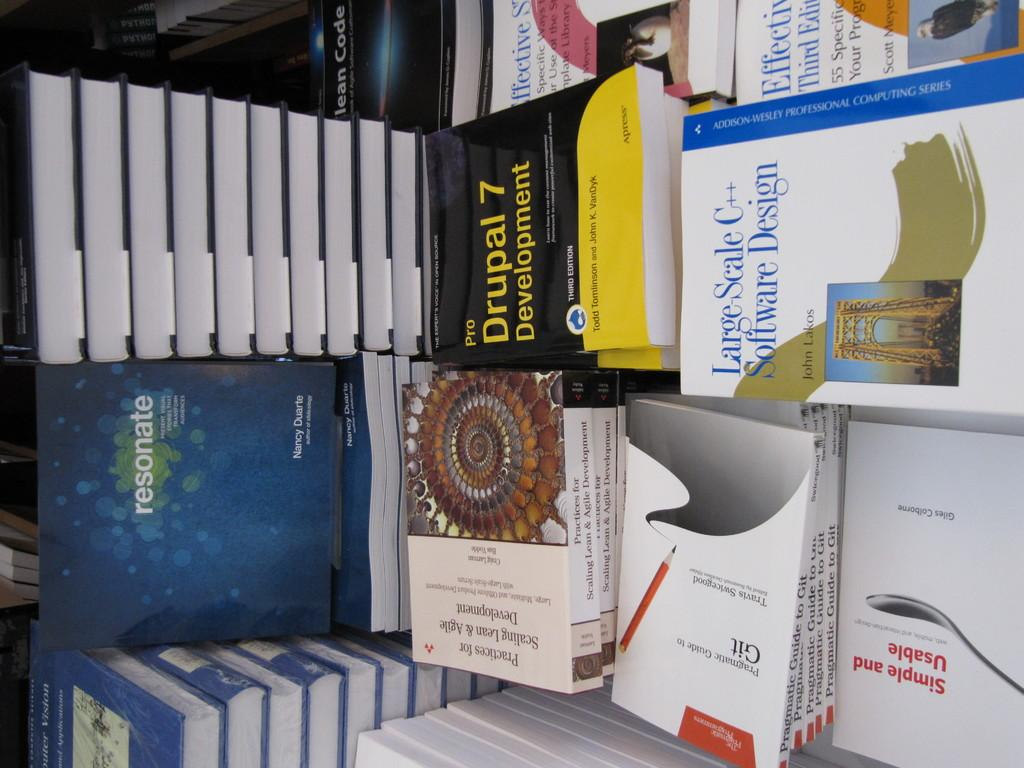<image>
Share a concise interpretation of the image provided. A bunch of book and one of them is about Drupal 7 Development. 